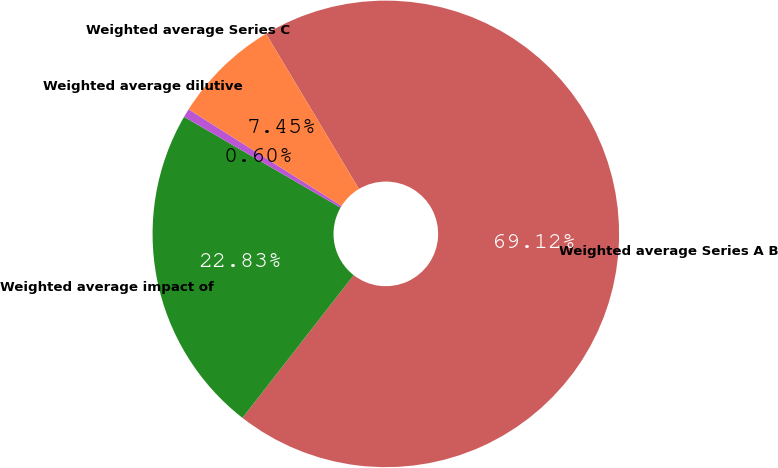Convert chart. <chart><loc_0><loc_0><loc_500><loc_500><pie_chart><fcel>Weighted average Series A B<fcel>Weighted average impact of<fcel>Weighted average dilutive<fcel>Weighted average Series C<nl><fcel>69.11%<fcel>22.83%<fcel>0.6%<fcel>7.45%<nl></chart> 